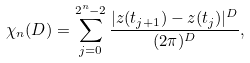Convert formula to latex. <formula><loc_0><loc_0><loc_500><loc_500>\chi _ { n } ( D ) = \sum _ { j = 0 } ^ { 2 ^ { n } - 2 } \frac { | z ( t _ { j + 1 } ) - z ( t _ { j } ) | ^ { D } } { ( 2 \pi ) ^ { D } } ,</formula> 